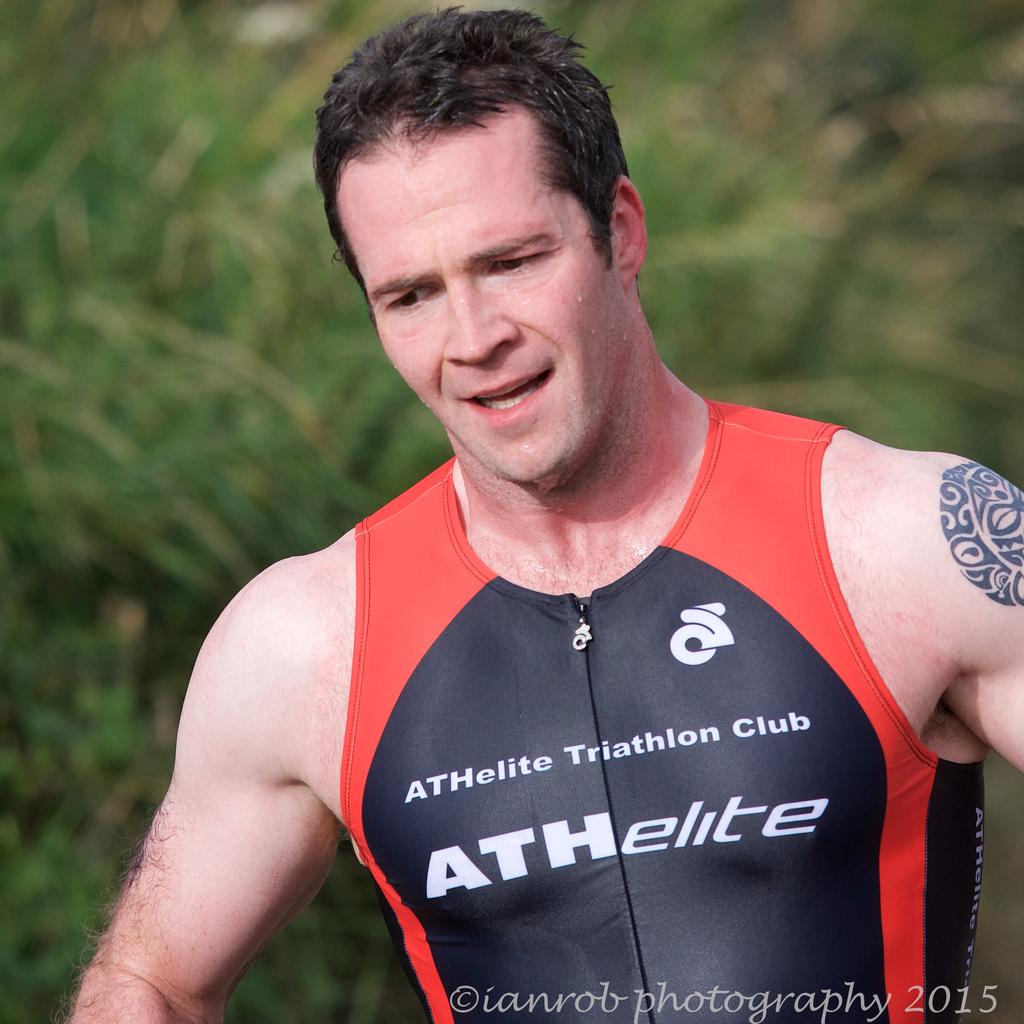<image>
Render a clear and concise summary of the photo. a man that has a shirt on that says athelite 